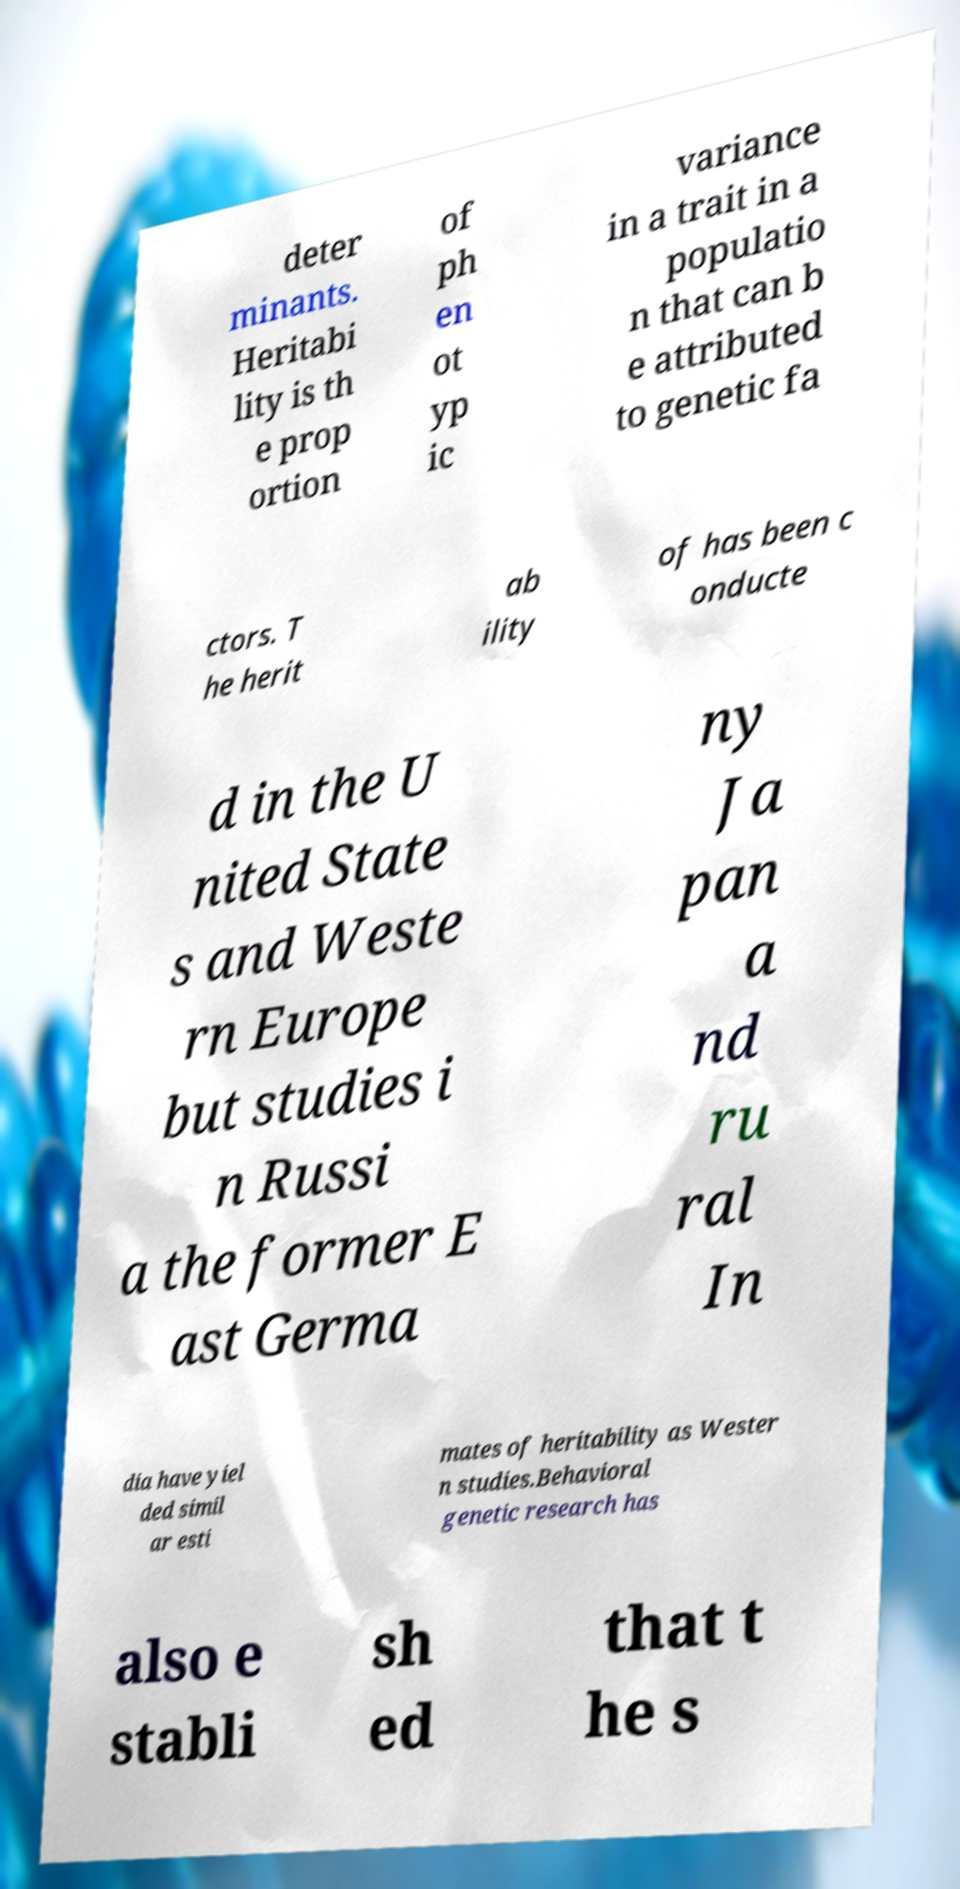There's text embedded in this image that I need extracted. Can you transcribe it verbatim? deter minants. Heritabi lity is th e prop ortion of ph en ot yp ic variance in a trait in a populatio n that can b e attributed to genetic fa ctors. T he herit ab ility of has been c onducte d in the U nited State s and Weste rn Europe but studies i n Russi a the former E ast Germa ny Ja pan a nd ru ral In dia have yiel ded simil ar esti mates of heritability as Wester n studies.Behavioral genetic research has also e stabli sh ed that t he s 